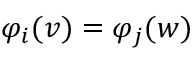<formula> <loc_0><loc_0><loc_500><loc_500>\varphi _ { i } ( v ) = \varphi _ { j } ( w )</formula> 